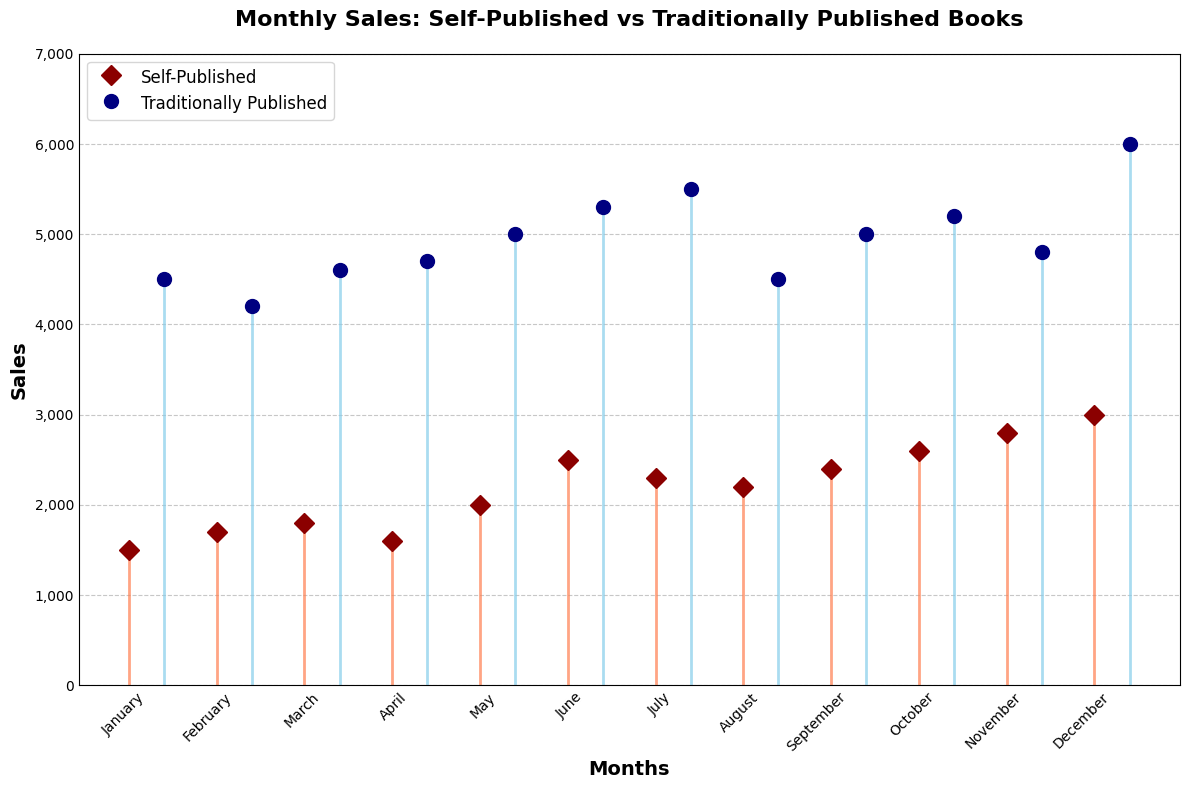What are the colors used for Self-Published and Traditionally Published sales? The stem plot uses coral for Self-Published and sky blue for Traditionally Published sales. These colors distinguish the two sales types visually.
Answer: Coral and sky blue How many months of data are displayed in the chart? The x-axis shows the months from January to December, which indicates that there are 12 months of data displayed in the chart.
Answer: 12 Which month has the highest sales for self-published books? By looking at the heights of the stems representing self-published sales, December has the highest value at 3000.
Answer: December What is the total sales for Traditionally Published books in June and July combined? The sales for Traditionally Published books in June are 5300 and in July are 5500. Adding these two values together gives 5300 + 5500 = 10800.
Answer: 10800 Which month shows the greatest difference in sales between Self-Published and Traditionally Published books? Observe the difference between the heights of the stems in each month; December stands out with 3000 for Self-Published and 6000 for Traditionally Published, making the difference 6000 - 3000 = 3000.
Answer: December How does the average sales for Self-Published books compare to that for Traditionally Published books? To find the average, sum the sales values and divide by the number of months. For Self-Published, (1500+1700+1800+1600+2000+2500+2300+2200+2400+2600+2800+3000)/12 = 2150; for Traditionally Published, (4500+4200+4600+4700+5000+5300+5500+4500+5000+5200+4800+6000)/12 = 4933.33. The average sales are higher for Traditionally Published books.
Answer: Traditionally Published Are there any months where the sales for Self-Published books exceed those of Traditionally Published books? By comparing the stems for each month, there are no months where the Self-Published sales exceed Traditionally Published sales; the stems for Traditionally Published are always higher.
Answer: No What is the sales trend for Self-Published books from January to December? The sales for Self-Published books generally increase from January (1500) to December (3000) with some fluctuations, particularly lower values in April and August.
Answer: Increasing trend Does November have higher sales in both categories compared to the previous month (October)? For Self-Published, November has 2800 compared to October's 2600, and for Traditionally Published, November has 4800 compared to October's 5200. So, only the Self-Published category shows an increase.
Answer: Only Self-Published in November 